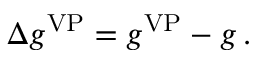Convert formula to latex. <formula><loc_0><loc_0><loc_500><loc_500>\Delta { g } ^ { V P } = g ^ { V P } - g \, .</formula> 